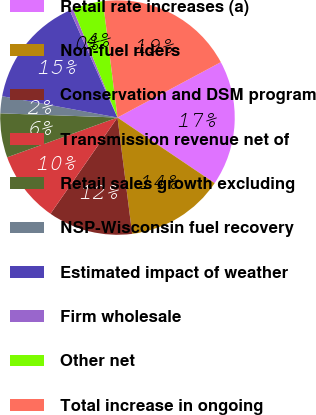<chart> <loc_0><loc_0><loc_500><loc_500><pie_chart><fcel>Retail rate increases (a)<fcel>Non-fuel riders<fcel>Conservation and DSM program<fcel>Transmission revenue net of<fcel>Retail sales growth excluding<fcel>NSP-Wisconsin fuel recovery<fcel>Estimated impact of weather<fcel>Firm wholesale<fcel>Other net<fcel>Total increase in ongoing<nl><fcel>17.28%<fcel>13.55%<fcel>11.68%<fcel>9.81%<fcel>6.08%<fcel>2.34%<fcel>15.42%<fcel>0.48%<fcel>4.21%<fcel>19.15%<nl></chart> 